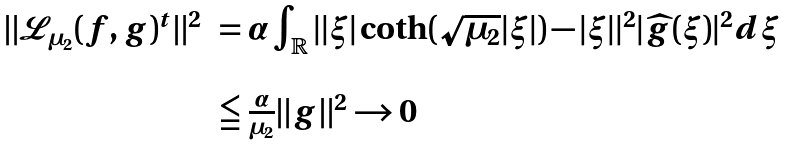<formula> <loc_0><loc_0><loc_500><loc_500>\begin{array} { l l l } \| \mathcal { L } _ { \mu _ { 2 } } ( f , g ) ^ { t } \| ^ { 2 } & = \alpha \int _ { \mathbb { R } } | | \xi | \coth ( \sqrt { \mu _ { 2 } } | \xi | ) - | \xi | | ^ { 2 } | \widehat { g } ( \xi ) | ^ { 2 } d \xi \\ \\ & \leqq \frac { \alpha } { \mu _ { 2 } } \| g \| ^ { 2 } \to 0 \end{array}</formula> 